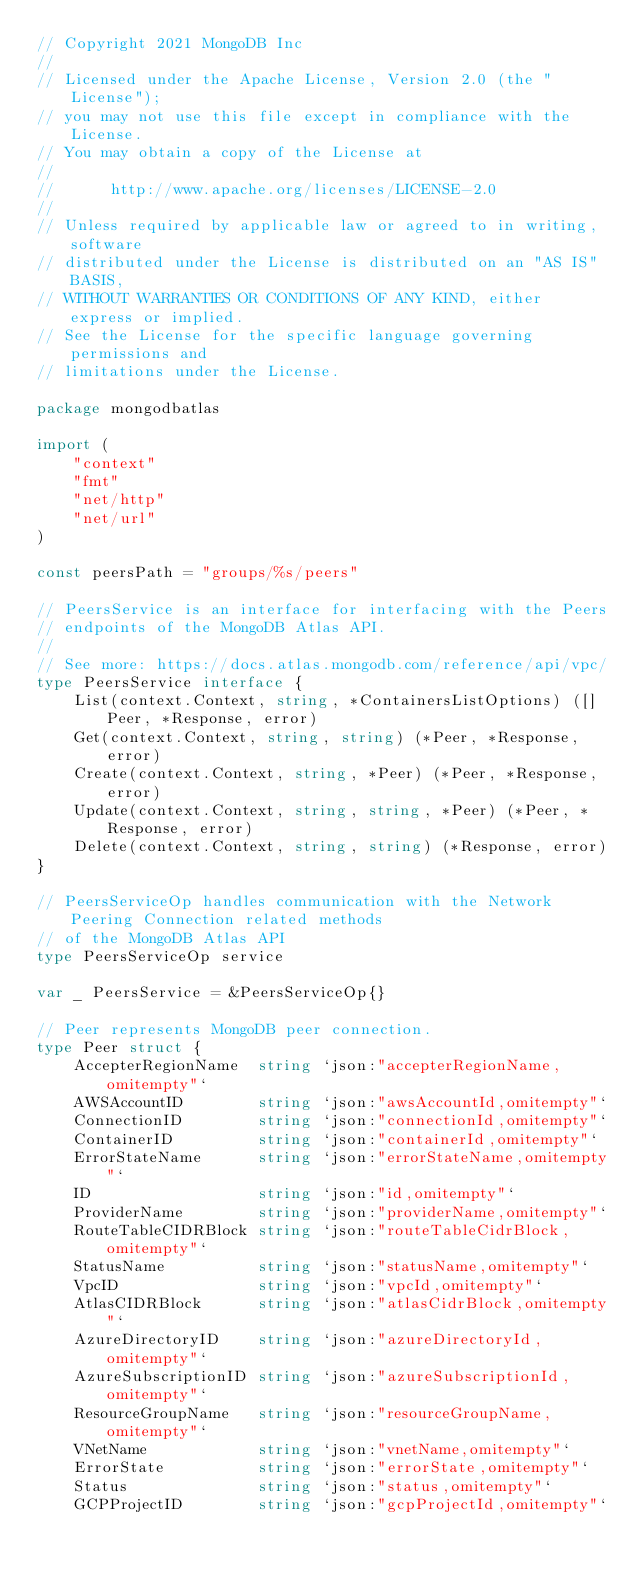Convert code to text. <code><loc_0><loc_0><loc_500><loc_500><_Go_>// Copyright 2021 MongoDB Inc
//
// Licensed under the Apache License, Version 2.0 (the "License");
// you may not use this file except in compliance with the License.
// You may obtain a copy of the License at
//
//      http://www.apache.org/licenses/LICENSE-2.0
//
// Unless required by applicable law or agreed to in writing, software
// distributed under the License is distributed on an "AS IS" BASIS,
// WITHOUT WARRANTIES OR CONDITIONS OF ANY KIND, either express or implied.
// See the License for the specific language governing permissions and
// limitations under the License.

package mongodbatlas

import (
	"context"
	"fmt"
	"net/http"
	"net/url"
)

const peersPath = "groups/%s/peers"

// PeersService is an interface for interfacing with the Peers
// endpoints of the MongoDB Atlas API.
//
// See more: https://docs.atlas.mongodb.com/reference/api/vpc/
type PeersService interface {
	List(context.Context, string, *ContainersListOptions) ([]Peer, *Response, error)
	Get(context.Context, string, string) (*Peer, *Response, error)
	Create(context.Context, string, *Peer) (*Peer, *Response, error)
	Update(context.Context, string, string, *Peer) (*Peer, *Response, error)
	Delete(context.Context, string, string) (*Response, error)
}

// PeersServiceOp handles communication with the Network Peering Connection related methods
// of the MongoDB Atlas API
type PeersServiceOp service

var _ PeersService = &PeersServiceOp{}

// Peer represents MongoDB peer connection.
type Peer struct {
	AccepterRegionName  string `json:"accepterRegionName,omitempty"`
	AWSAccountID        string `json:"awsAccountId,omitempty"`
	ConnectionID        string `json:"connectionId,omitempty"`
	ContainerID         string `json:"containerId,omitempty"`
	ErrorStateName      string `json:"errorStateName,omitempty"`
	ID                  string `json:"id,omitempty"`
	ProviderName        string `json:"providerName,omitempty"`
	RouteTableCIDRBlock string `json:"routeTableCidrBlock,omitempty"`
	StatusName          string `json:"statusName,omitempty"`
	VpcID               string `json:"vpcId,omitempty"`
	AtlasCIDRBlock      string `json:"atlasCidrBlock,omitempty"`
	AzureDirectoryID    string `json:"azureDirectoryId,omitempty"`
	AzureSubscriptionID string `json:"azureSubscriptionId,omitempty"`
	ResourceGroupName   string `json:"resourceGroupName,omitempty"`
	VNetName            string `json:"vnetName,omitempty"`
	ErrorState          string `json:"errorState,omitempty"`
	Status              string `json:"status,omitempty"`
	GCPProjectID        string `json:"gcpProjectId,omitempty"`</code> 